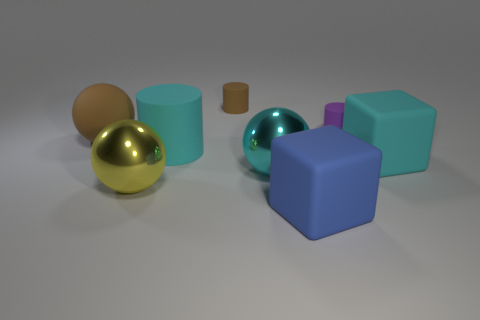What is the blue block made of?
Ensure brevity in your answer.  Rubber. There is a sphere that is the same color as the large cylinder; what size is it?
Offer a very short reply. Large. Do the large brown object and the matte thing in front of the yellow sphere have the same shape?
Give a very brief answer. No. What material is the brown thing left of the brown thing behind the tiny cylinder on the right side of the large blue cube?
Make the answer very short. Rubber. How many large brown shiny cylinders are there?
Your response must be concise. 0. What number of blue things are either balls or large matte objects?
Offer a very short reply. 1. How many other objects are there of the same shape as the large yellow shiny thing?
Offer a very short reply. 2. Do the large sphere behind the cyan matte cylinder and the big metallic sphere that is right of the big cylinder have the same color?
Provide a succinct answer. No. How many big things are brown spheres or gray cylinders?
Provide a succinct answer. 1. There is a yellow thing that is the same shape as the cyan metal thing; what size is it?
Your answer should be compact. Large. 